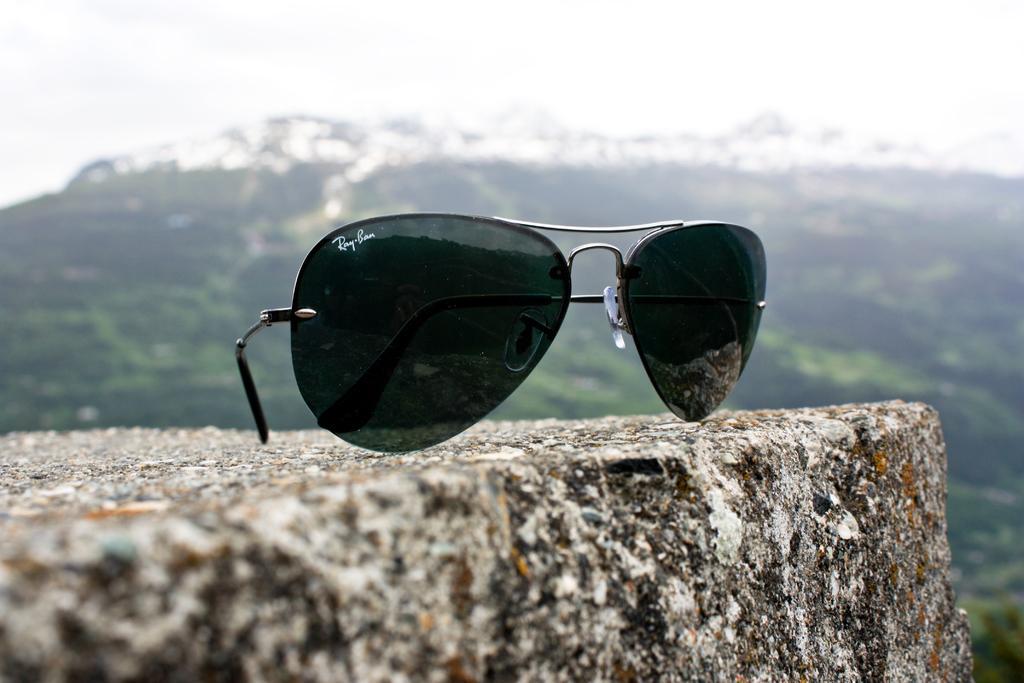How would you summarize this image in a sentence or two? In this picture we can see a ray ban sunglasses on a rock. Behind the ray ban sunglasses, there's a hill and a sky. 